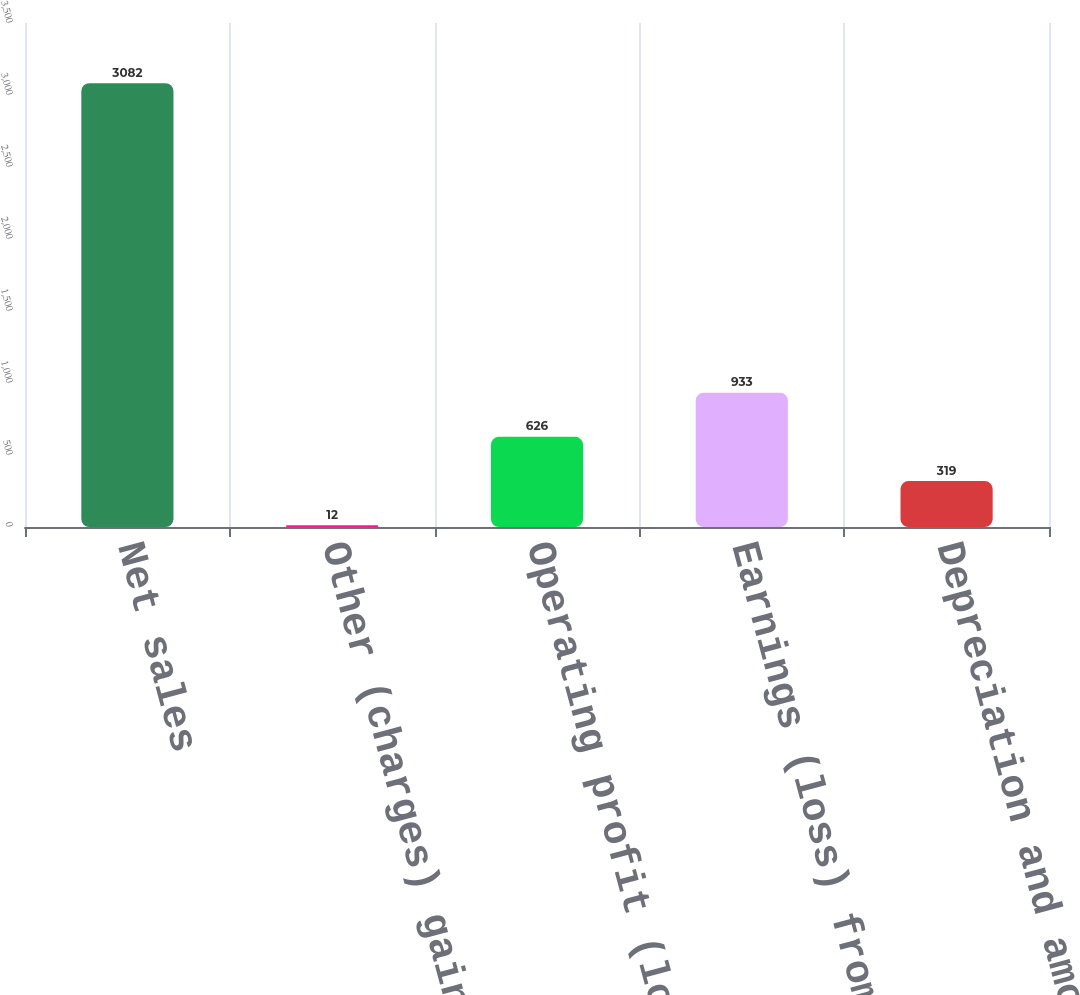Convert chart. <chart><loc_0><loc_0><loc_500><loc_500><bar_chart><fcel>Net sales<fcel>Other (charges) gains net<fcel>Operating profit (loss)<fcel>Earnings (loss) from<fcel>Depreciation and amortization<nl><fcel>3082<fcel>12<fcel>626<fcel>933<fcel>319<nl></chart> 